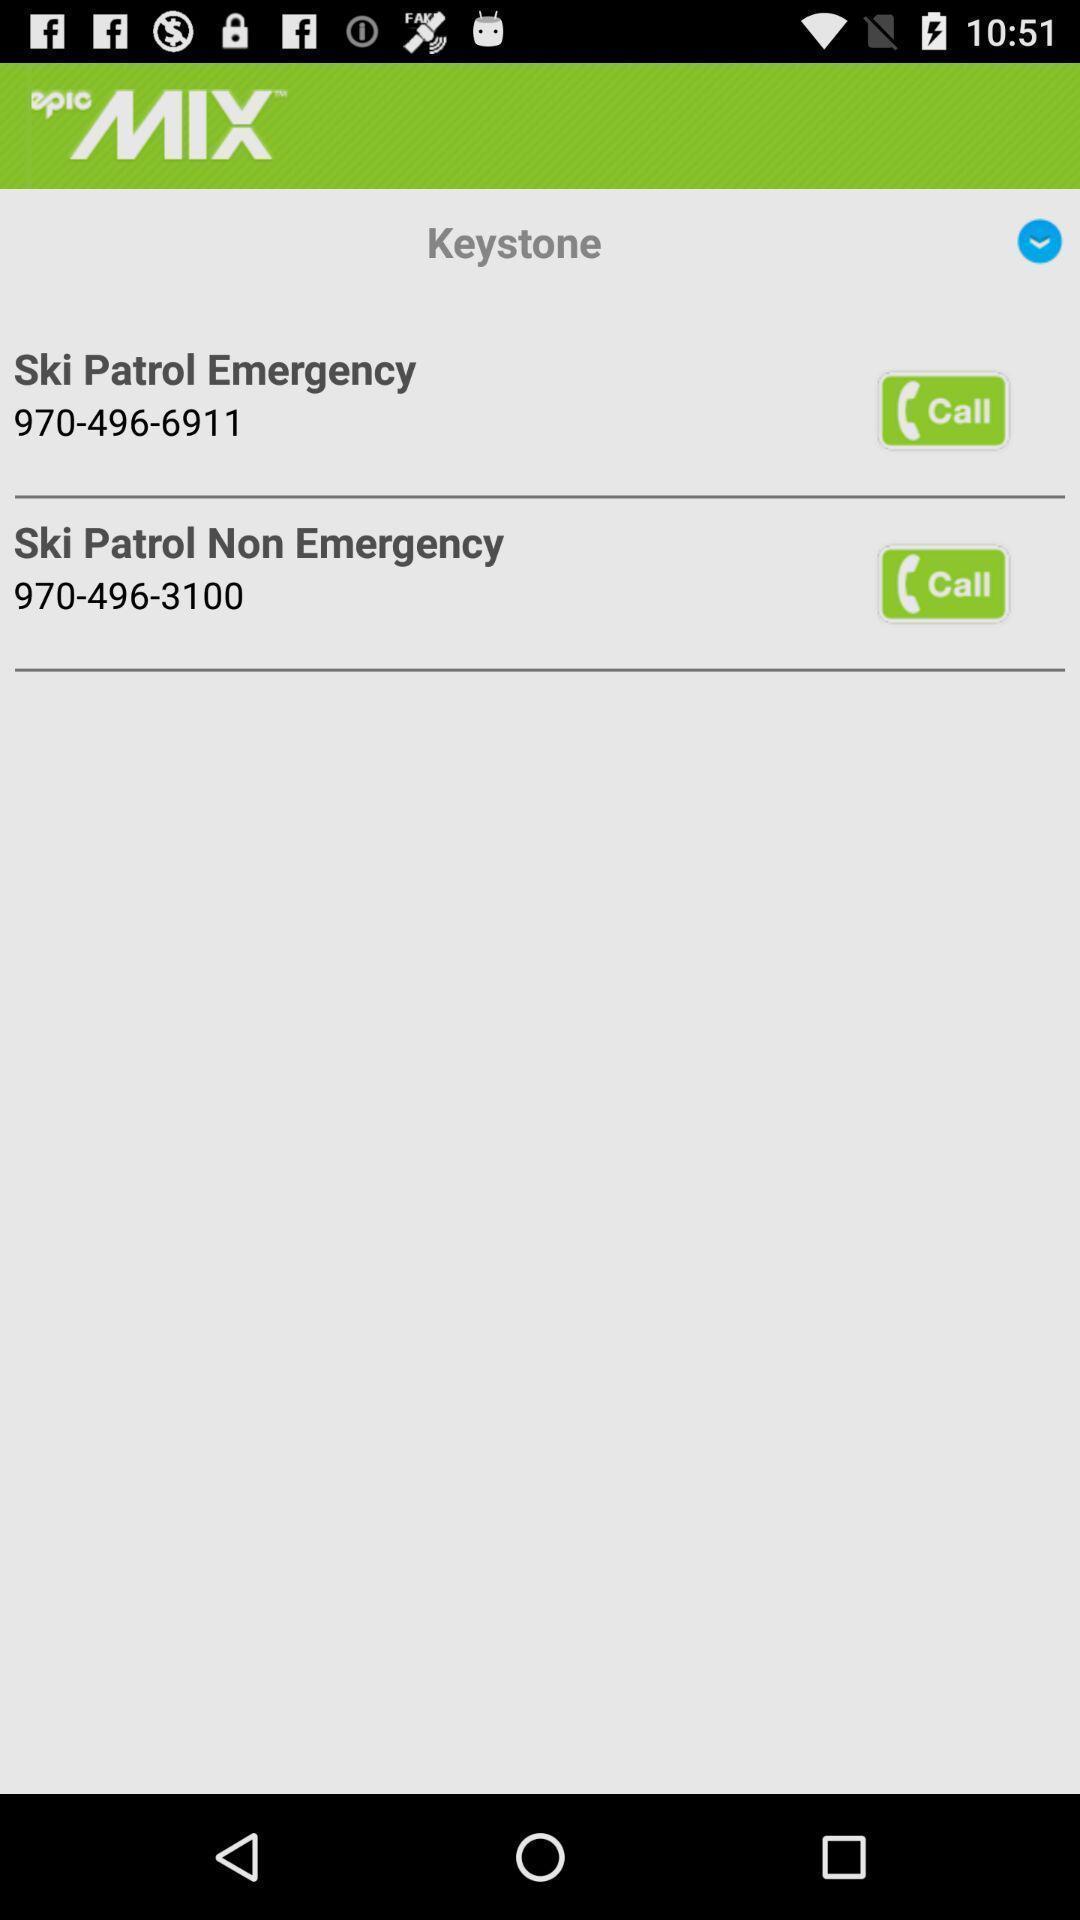Summarize the main components in this picture. Various emergency contacts list displayed. 